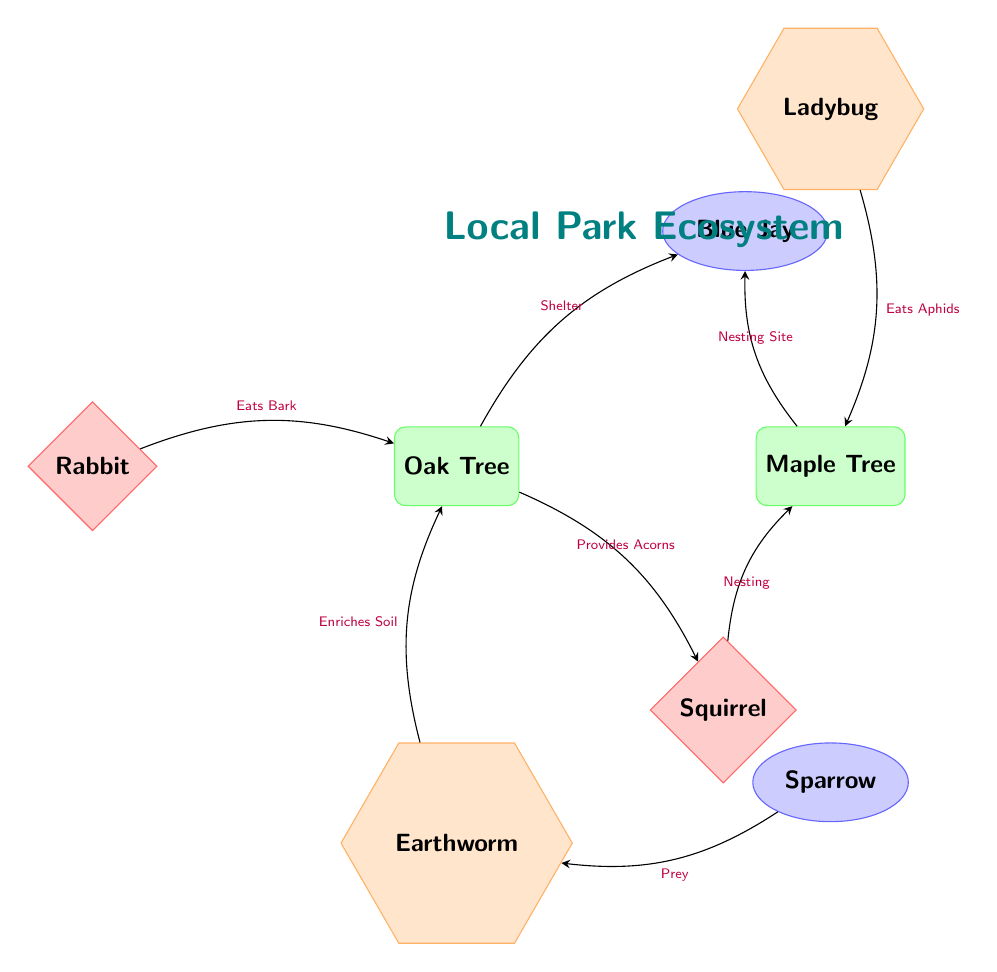What is the primary food source for the squirrel? The diagram indicates that the squirrel receives acorns from the oak tree, which is labeled as "Provides Acorns". The arrow connecting the oak to the squirrel reinforces this relationship.
Answer: Acorns How many insects are present in the diagram? The diagram displays two insect nodes: Earthworm and Ladybug. Simply counting these nodes shows there are two insects.
Answer: 2 What role does the ladybug play in the maple tree's ecosystem? According to the diagram, the ladybug is shown to eat aphids on the maple tree, indicated by the label "Eats Aphids" pointing from the ladybug to the maple tree.
Answer: Eats Aphids What does the earthworm do for the oak tree? The arrow in the diagram labels the relationship between the earthworm and the oak tree as "Enriches Soil”. This suggests that the earthworm contributes positively to the oak's growth by improving the soil quality.
Answer: Enriches Soil Which bird nests in the maple tree? The diagram labels the blue jay as a bird that uses the maple tree for nesting, indicated by the arrow pointing from the maple tree to the blue jay along with the label "Nesting Site".
Answer: Blue Jay How many mammal species are represented in the ecosystem? The diagram depicts two mammals: Squirrel and Rabbit. Counting these nodes shows that there are two mammal species in the ecosystem.
Answer: 2 What type of tree provides shelter for the blue jay? The diagram clearly indicates that the blue jay finds shelter in the oak tree, as it's shown with an arrow labeled "Shelter" pointing from the oak to the blue jay.
Answer: Oak Tree What does the sparrow prey on in the ecosystem? The arrow in the diagram pointing from the sparrow to the earthworm is labeled "Prey", which states that the sparrow preys upon the earthworm as part of its diet.
Answer: Earthworm 